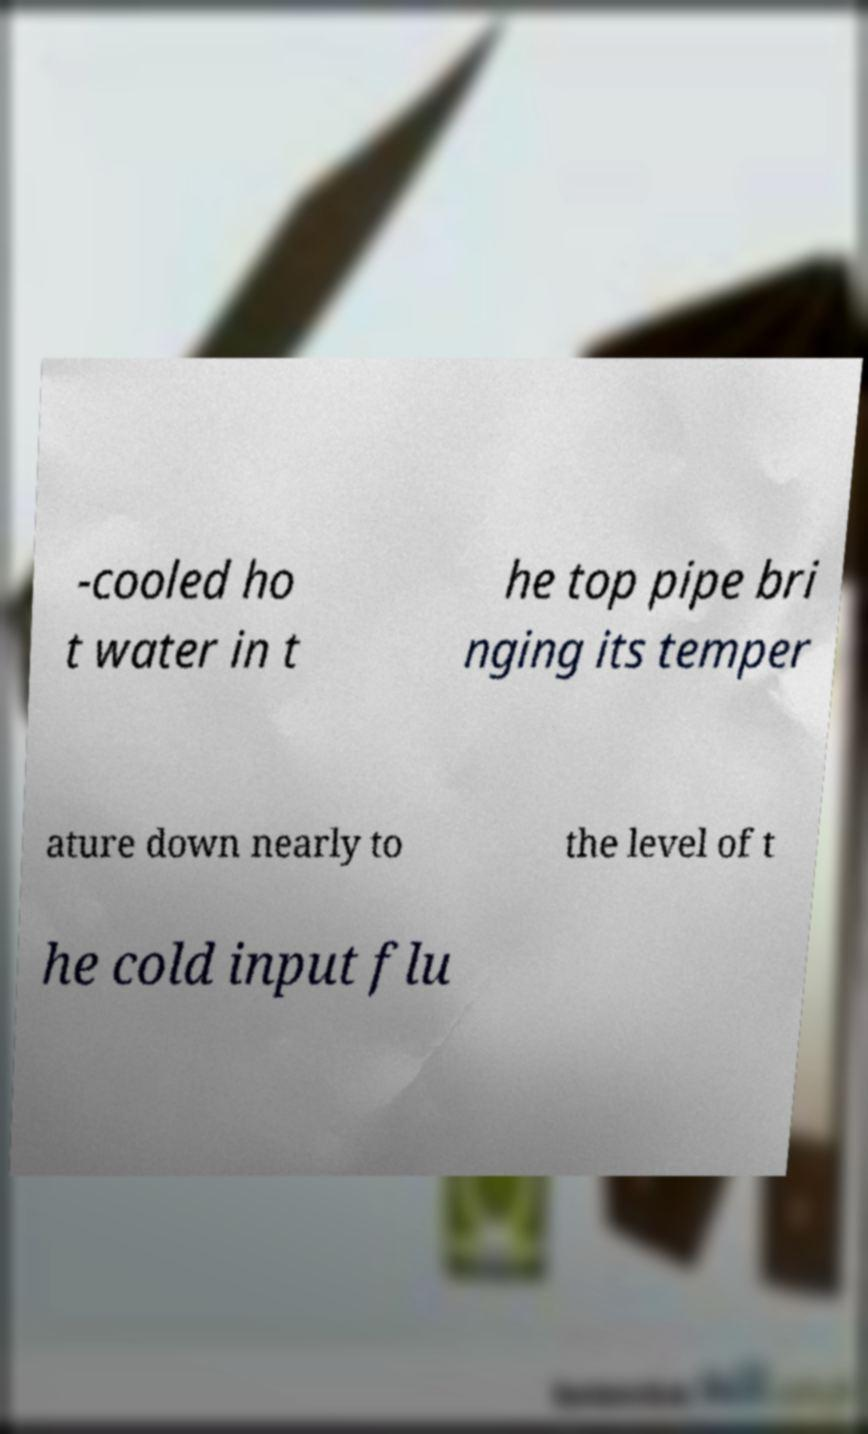Can you accurately transcribe the text from the provided image for me? -cooled ho t water in t he top pipe bri nging its temper ature down nearly to the level of t he cold input flu 